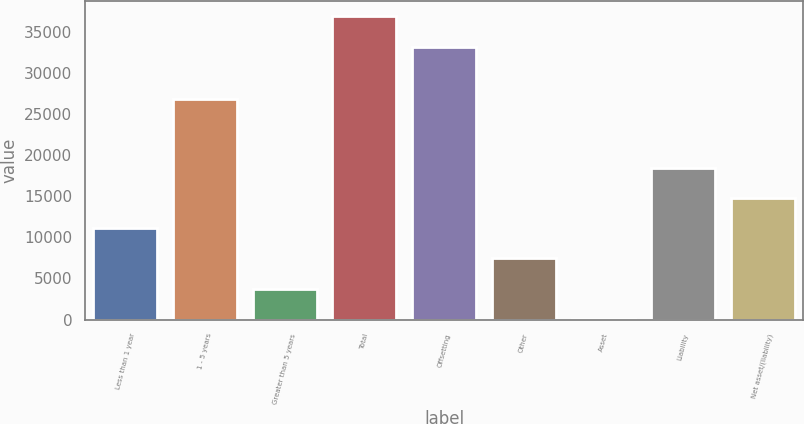<chart> <loc_0><loc_0><loc_500><loc_500><bar_chart><fcel>Less than 1 year<fcel>1 - 5 years<fcel>Greater than 5 years<fcel>Total<fcel>Offsetting<fcel>Other<fcel>Asset<fcel>Liability<fcel>Net asset/(liability)<nl><fcel>11109.7<fcel>26834<fcel>3757.9<fcel>36841<fcel>33112<fcel>7433.8<fcel>82<fcel>18461.5<fcel>14785.6<nl></chart> 